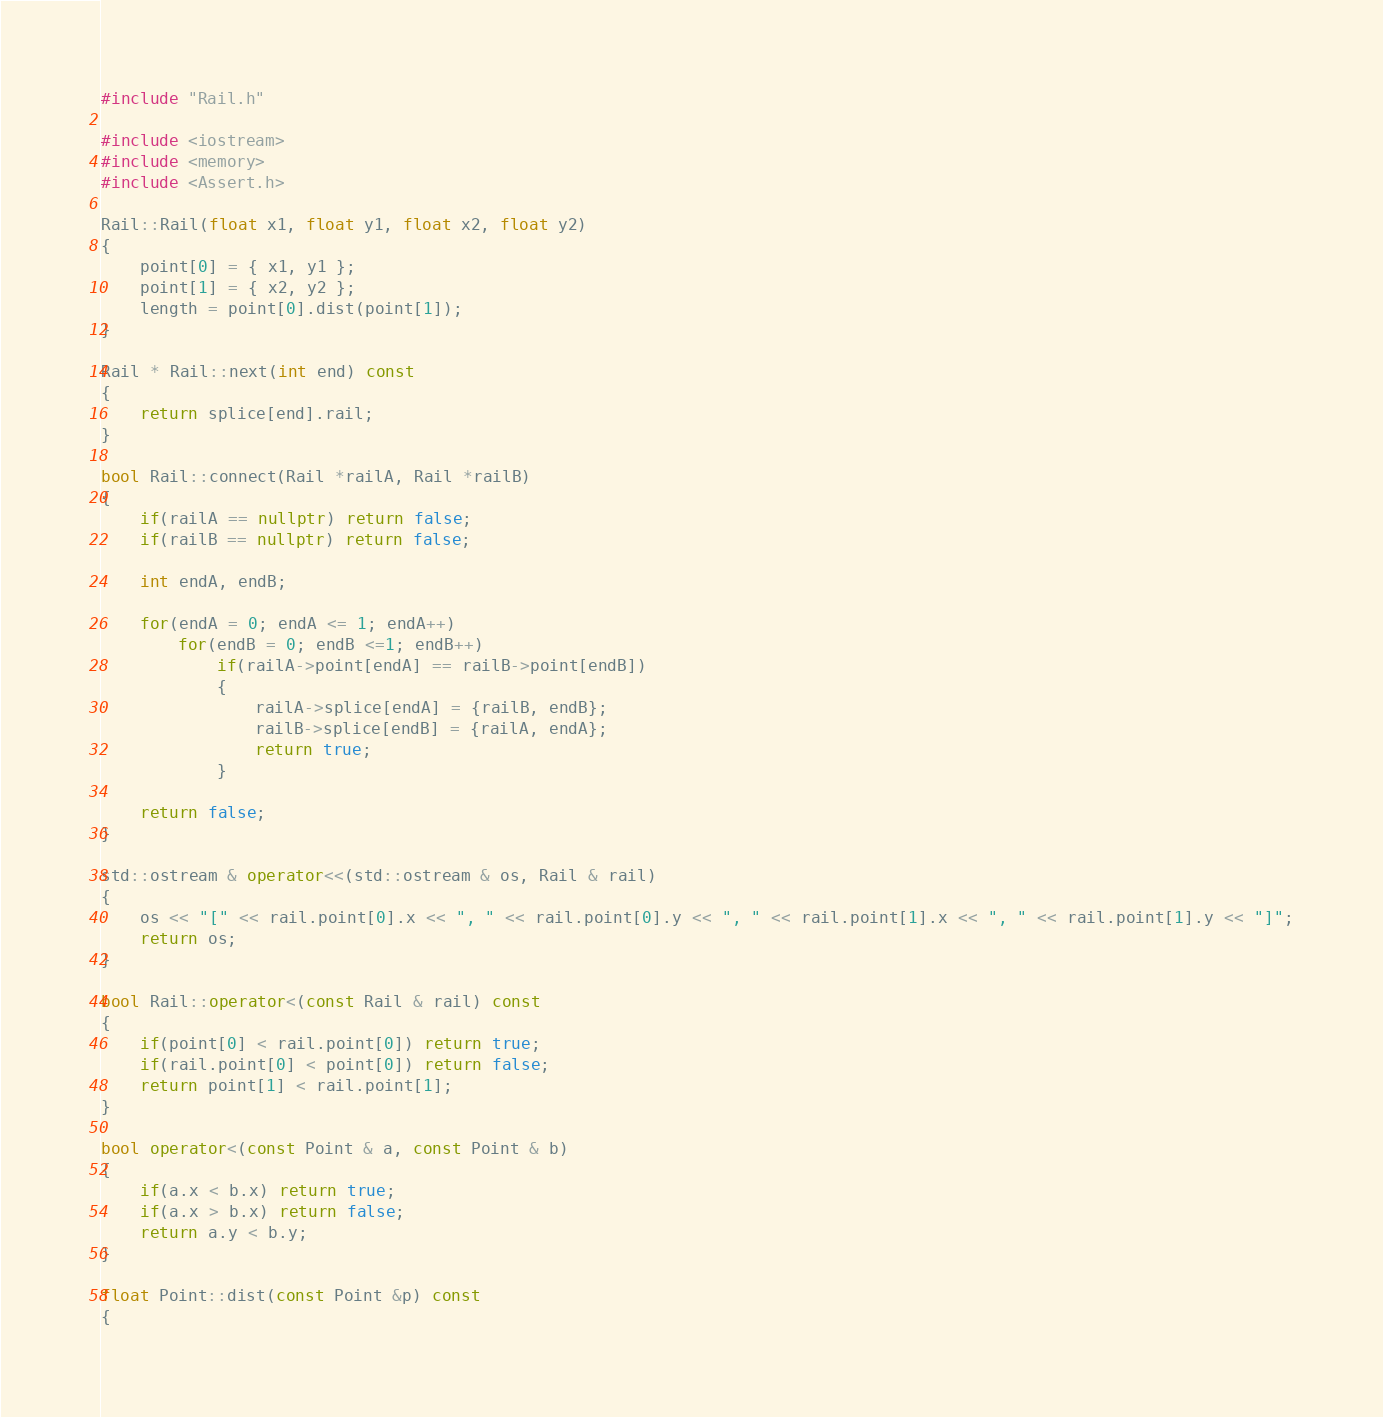Convert code to text. <code><loc_0><loc_0><loc_500><loc_500><_C++_>#include "Rail.h"

#include <iostream>
#include <memory>
#include <Assert.h>

Rail::Rail(float x1, float y1, float x2, float y2)
{
    point[0] = { x1, y1 };
    point[1] = { x2, y2 };
    length = point[0].dist(point[1]);
}

Rail * Rail::next(int end) const
{
    return splice[end].rail;
}

bool Rail::connect(Rail *railA, Rail *railB)
{
    if(railA == nullptr) return false;
    if(railB == nullptr) return false;

    int endA, endB;

    for(endA = 0; endA <= 1; endA++)
        for(endB = 0; endB <=1; endB++)
            if(railA->point[endA] == railB->point[endB])
            {
                railA->splice[endA] = {railB, endB};
                railB->splice[endB] = {railA, endA};
                return true;
            }

    return false;
}

std::ostream & operator<<(std::ostream & os, Rail & rail)
{
    os << "[" << rail.point[0].x << ", " << rail.point[0].y << ", " << rail.point[1].x << ", " << rail.point[1].y << "]";
    return os;
}

bool Rail::operator<(const Rail & rail) const
{
    if(point[0] < rail.point[0]) return true;
    if(rail.point[0] < point[0]) return false;
    return point[1] < rail.point[1];
}

bool operator<(const Point & a, const Point & b)
{
    if(a.x < b.x) return true;
    if(a.x > b.x) return false;
    return a.y < b.y;
}

float Point::dist(const Point &p) const
{</code> 